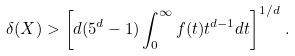Convert formula to latex. <formula><loc_0><loc_0><loc_500><loc_500>\delta ( X ) > \left [ d ( 5 ^ { d } - 1 ) \int _ { 0 } ^ { \infty } f ( t ) t ^ { d - 1 } d t \right ] ^ { 1 / d } \, .</formula> 